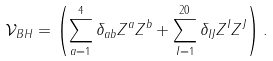Convert formula to latex. <formula><loc_0><loc_0><loc_500><loc_500>\mathcal { V } _ { B H } = \left ( \sum _ { a = 1 } ^ { 4 } \delta _ { a b } Z ^ { a } Z ^ { b } + \sum _ { I = 1 } ^ { 2 0 } \delta _ { I J } Z ^ { I } Z ^ { J } \right ) .</formula> 